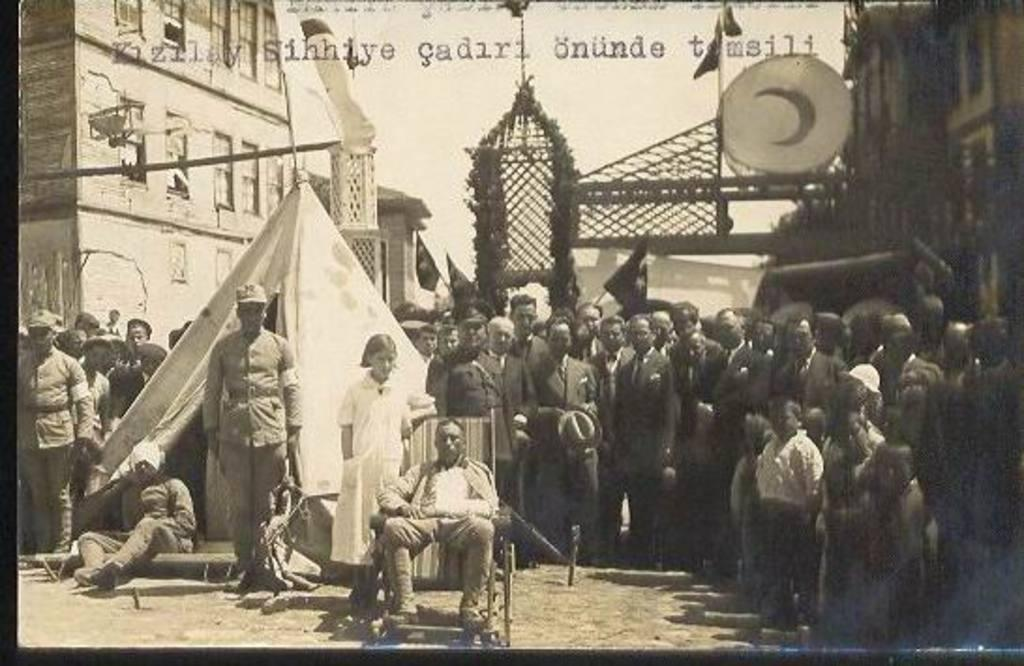What is the main subject in the foreground of the image? There is a person sitting on a chair in the foreground of the image. How many people are present in the image? There are many people in the image. What type of structure can be seen in the image? There is a tent in the image. What can be seen in the background of the image? There are buildings and an arch in the background of the image. What type of thrill can be seen on the person's face in the image? There is no indication of a thrill or emotion on the person's face in the image. Is there a doctor present in the image? There is no mention of a doctor or any medical professionals in the image. 